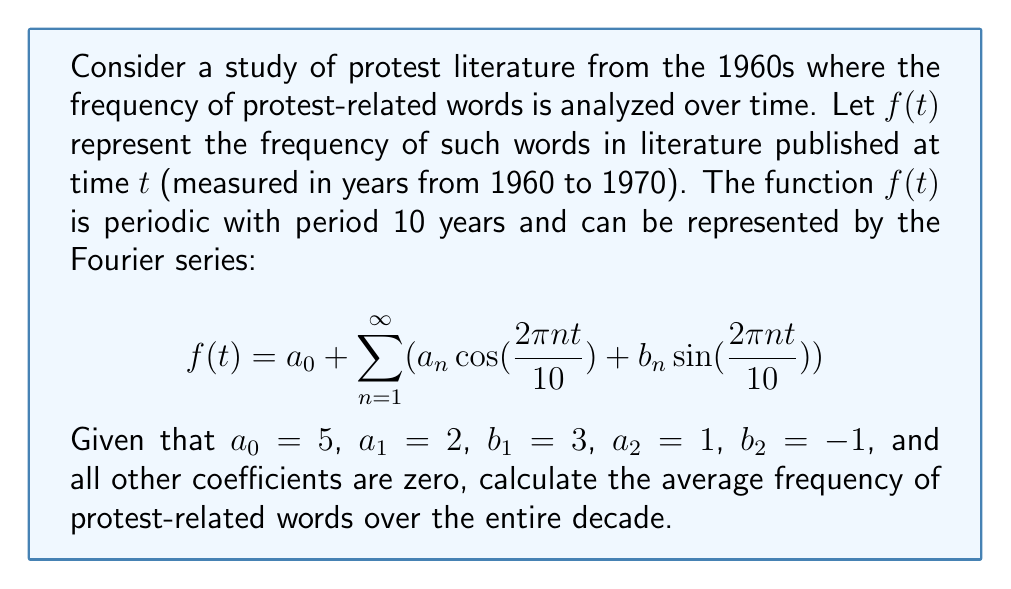Solve this math problem. To solve this problem, we need to understand the meaning of the Fourier series coefficients and how they relate to the average value of the function.

1) In a Fourier series, the coefficient $a_0$ represents twice the average value of the function over one period. This is because:

   $$a_0 = \frac{1}{T}\int_0^T f(t) dt$$

   where $T$ is the period of the function.

2) In this case, we're given that $a_0 = 5$. 

3) The average value of the function over one period is therefore:

   $$\text{Average} = \frac{a_0}{2} = \frac{5}{2} = 2.5$$

4) It's worth noting that the other coefficients ($a_n$ and $b_n$ for $n \geq 1$) do not affect the average value of the function. They contribute to the oscillations around this average.

5) The given information about $a_1$, $b_1$, $a_2$, and $b_2$ is not necessary for calculating the average, but it would be useful if we needed to plot the function or calculate its value at a specific time.

Therefore, the average frequency of protest-related words over the entire decade is 2.5.
Answer: 2.5 